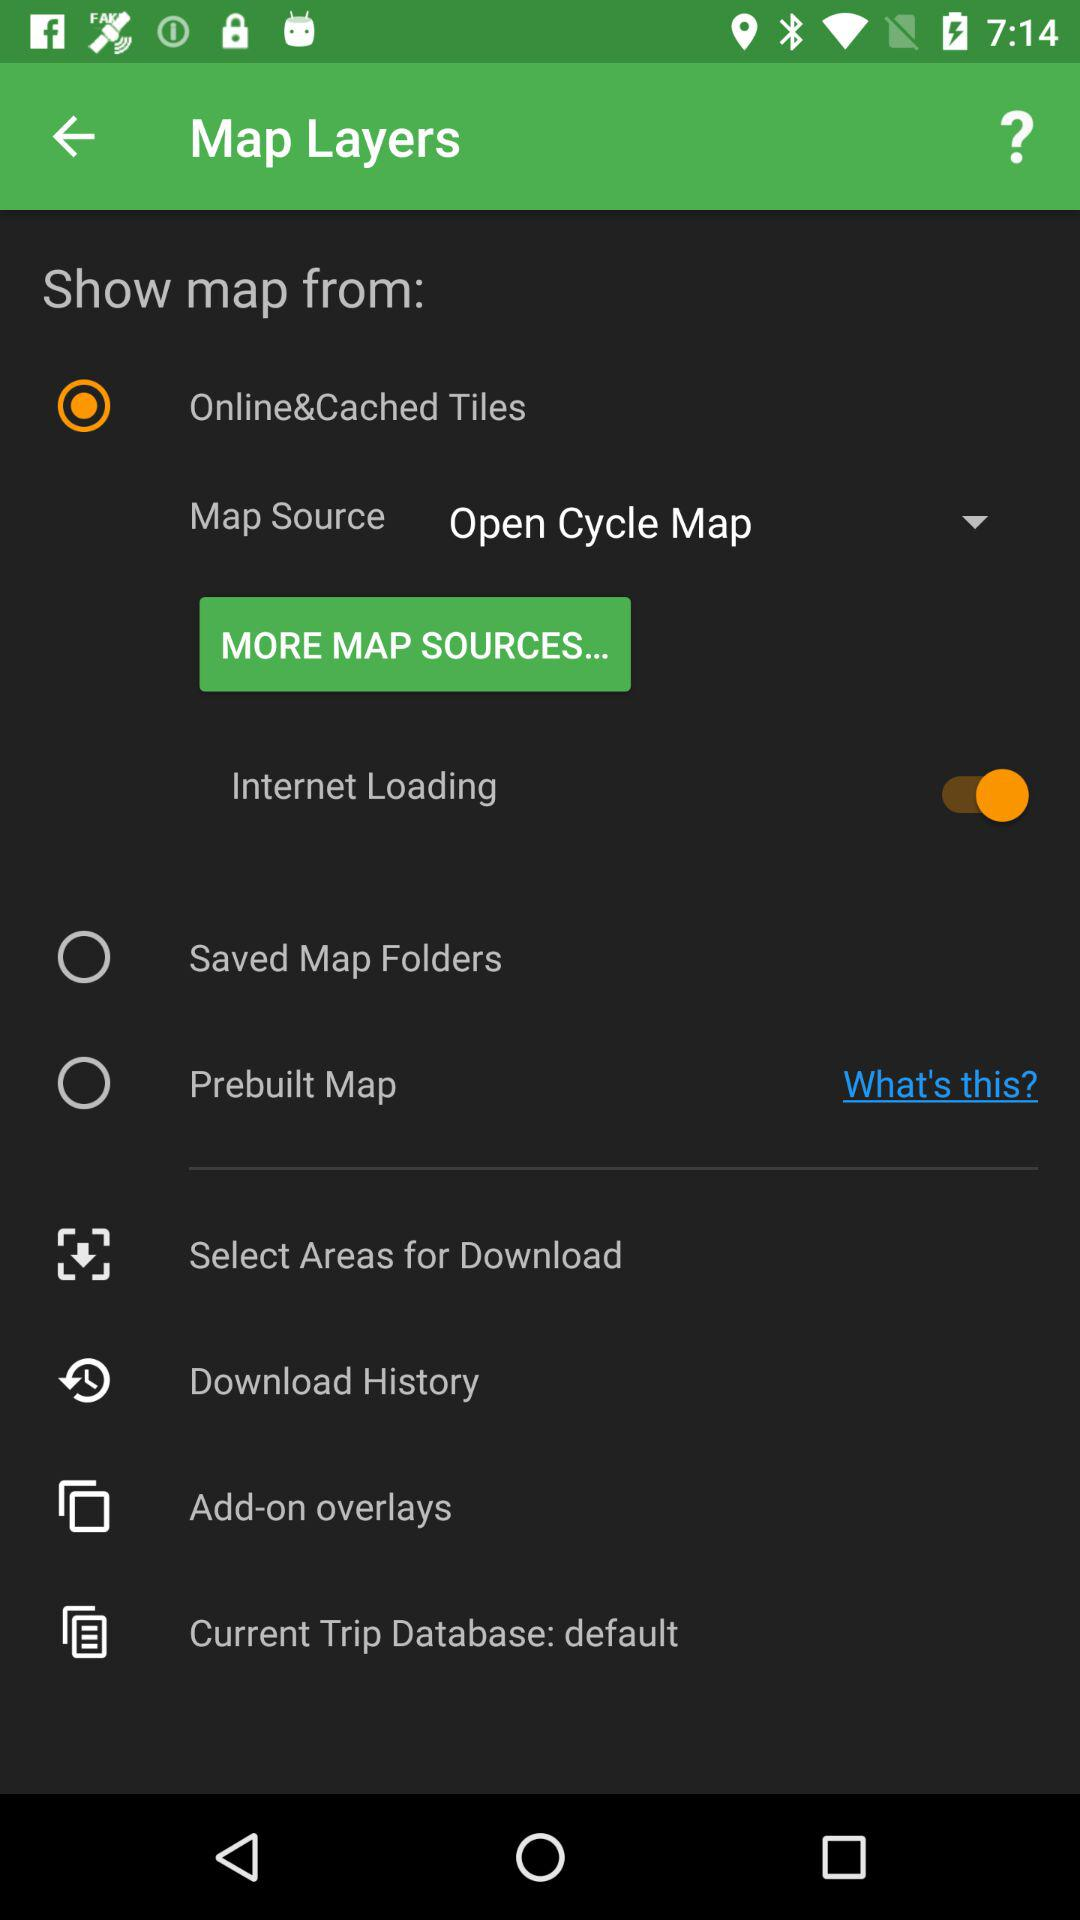What is the name of the application?
When the provided information is insufficient, respond with <no answer>. <no answer> 